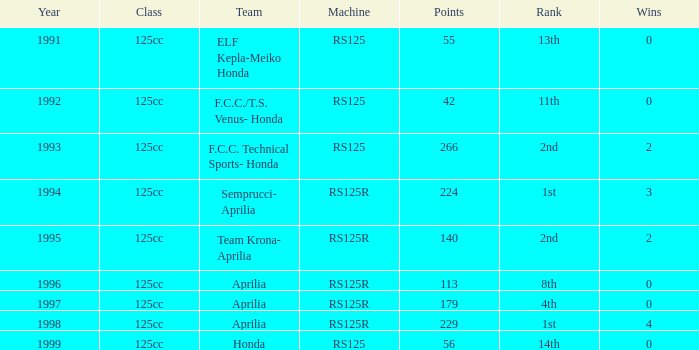Could you parse the entire table? {'header': ['Year', 'Class', 'Team', 'Machine', 'Points', 'Rank', 'Wins'], 'rows': [['1991', '125cc', 'ELF Kepla-Meiko Honda', 'RS125', '55', '13th', '0'], ['1992', '125cc', 'F.C.C./T.S. Venus- Honda', 'RS125', '42', '11th', '0'], ['1993', '125cc', 'F.C.C. Technical Sports- Honda', 'RS125', '266', '2nd', '2'], ['1994', '125cc', 'Semprucci- Aprilia', 'RS125R', '224', '1st', '3'], ['1995', '125cc', 'Team Krona- Aprilia', 'RS125R', '140', '2nd', '2'], ['1996', '125cc', 'Aprilia', 'RS125R', '113', '8th', '0'], ['1997', '125cc', 'Aprilia', 'RS125R', '179', '4th', '0'], ['1998', '125cc', 'Aprilia', 'RS125R', '229', '1st', '4'], ['1999', '125cc', 'Honda', 'RS125', '56', '14th', '0']]} Which class included a machine possessing an rs125r, exceeding 113 points, and a rank of 4th? 125cc. 